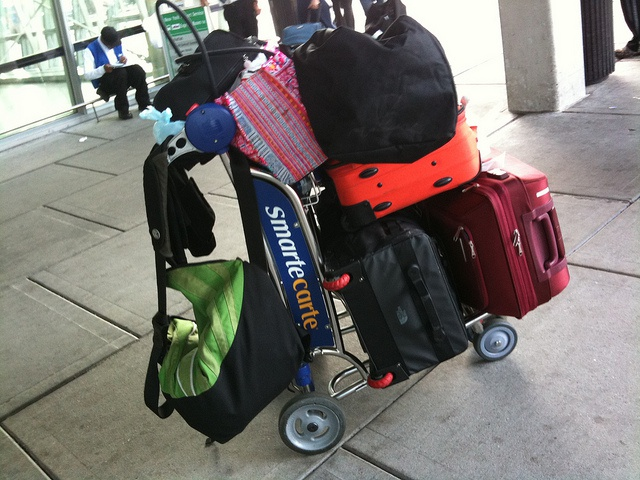Describe the objects in this image and their specific colors. I can see backpack in ivory, black, darkgreen, and green tones, backpack in ivory, black, gray, and salmon tones, suitcase in ivory, black, and purple tones, suitcase in ivory, black, maroon, and brown tones, and suitcase in ivory, red, black, and salmon tones in this image. 